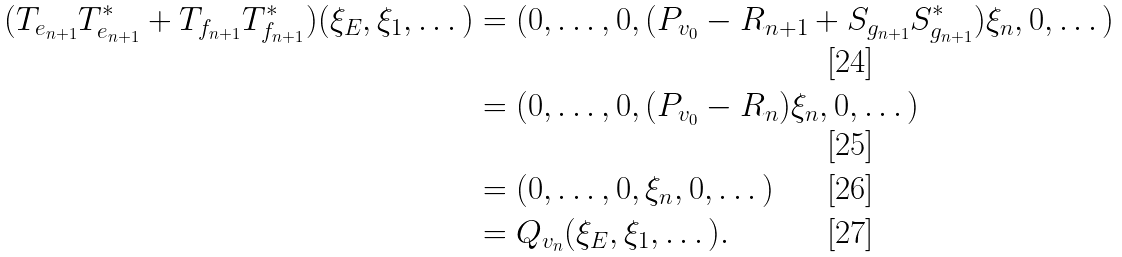<formula> <loc_0><loc_0><loc_500><loc_500>( T _ { e _ { n + 1 } } T _ { e _ { n + 1 } } ^ { * } + T _ { f _ { n + 1 } } T _ { f _ { n + 1 } } ^ { * } ) ( \xi _ { E } , \xi _ { 1 } , \dots ) & = ( 0 , \dots , 0 , ( P _ { v _ { 0 } } - R _ { n + 1 } + S _ { g _ { n + 1 } } S _ { g _ { n + 1 } } ^ { * } ) \xi _ { n } , 0 , \dots ) \\ & = ( 0 , \dots , 0 , ( P _ { v _ { 0 } } - R _ { n } ) \xi _ { n } , 0 , \dots ) \\ & = ( 0 , \dots , 0 , \xi _ { n } , 0 , \dots ) \\ & = Q _ { v _ { n } } ( \xi _ { E } , \xi _ { 1 } , \dots ) .</formula> 